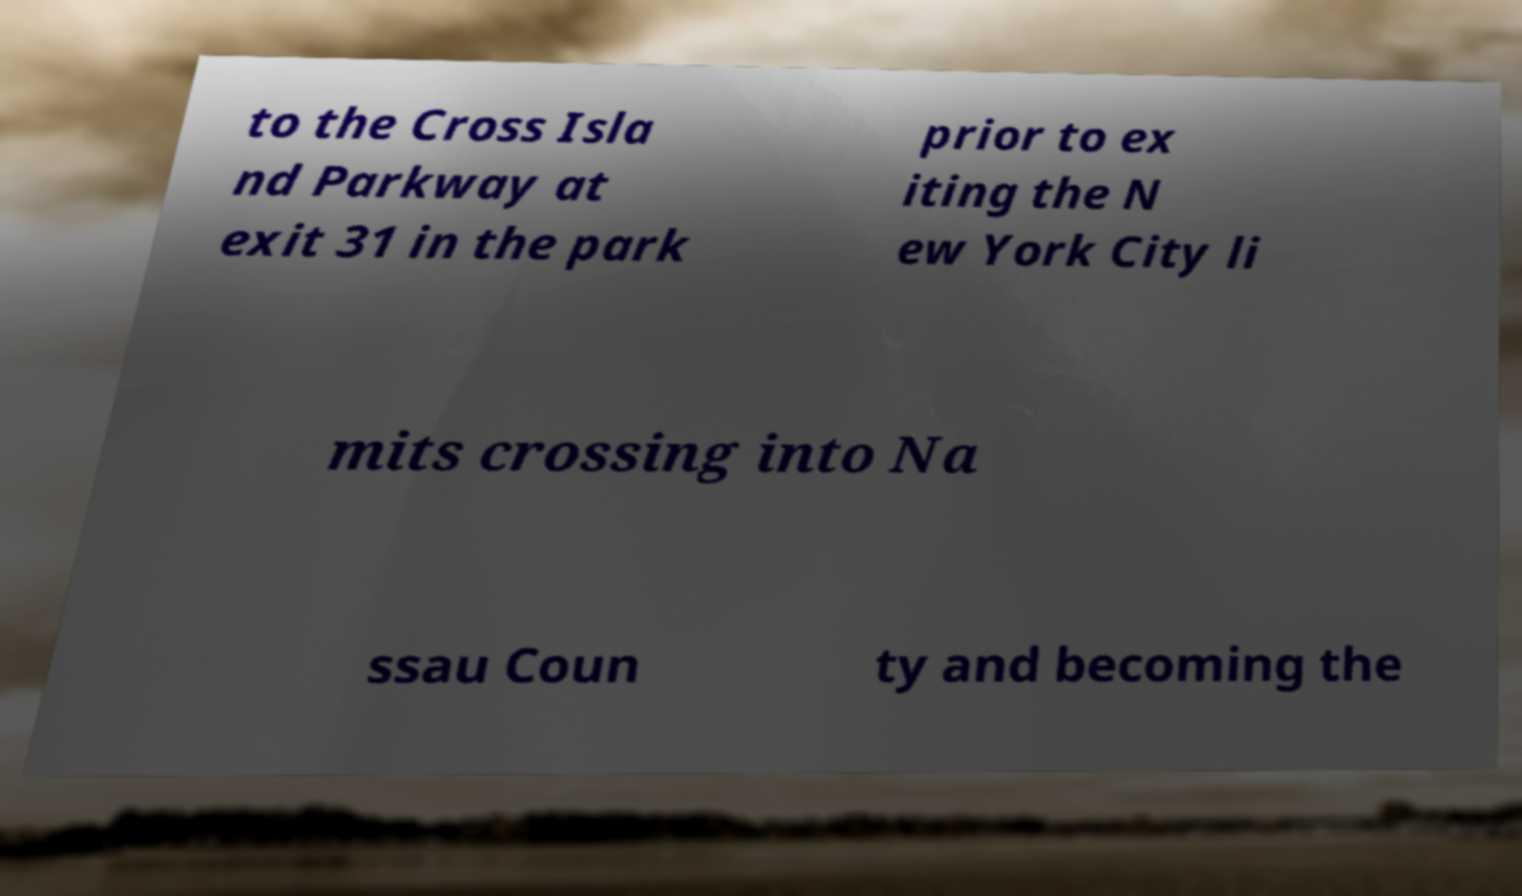Can you read and provide the text displayed in the image?This photo seems to have some interesting text. Can you extract and type it out for me? to the Cross Isla nd Parkway at exit 31 in the park prior to ex iting the N ew York City li mits crossing into Na ssau Coun ty and becoming the 